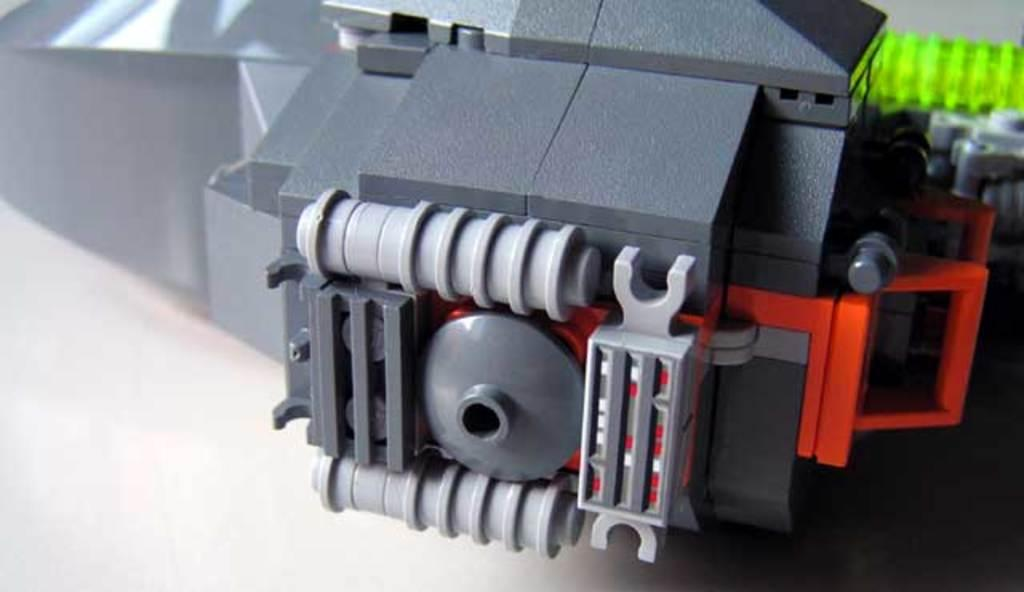What is the main object in the foreground of the image? There is a toy in the foreground of the image. Can you describe any other objects or furniture in the image? Yes, there is a table in the image. What type of crops is the farmer harvesting in the image? There is no farmer or crops present in the image; it features a toy and a table. What is the wren doing in the image? There is no wren present in the image. 